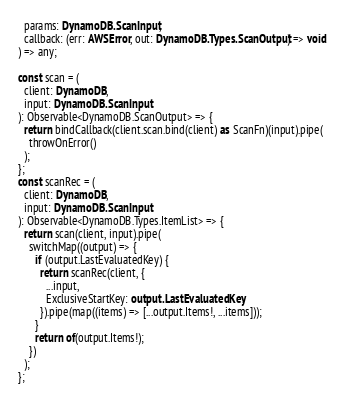<code> <loc_0><loc_0><loc_500><loc_500><_TypeScript_>  params: DynamoDB.ScanInput,
  callback: (err: AWSError, out: DynamoDB.Types.ScanOutput) => void
) => any;

const scan = (
  client: DynamoDB,
  input: DynamoDB.ScanInput
): Observable<DynamoDB.ScanOutput> => {
  return bindCallback(client.scan.bind(client) as ScanFn)(input).pipe(
    throwOnError()
  );
};
const scanRec = (
  client: DynamoDB,
  input: DynamoDB.ScanInput
): Observable<DynamoDB.Types.ItemList> => {
  return scan(client, input).pipe(
    switchMap((output) => {
      if (output.LastEvaluatedKey) {
        return scanRec(client, {
          ...input,
          ExclusiveStartKey: output.LastEvaluatedKey,
        }).pipe(map((items) => [...output.Items!, ...items]));
      }
      return of(output.Items!);
    })
  );
};
</code> 